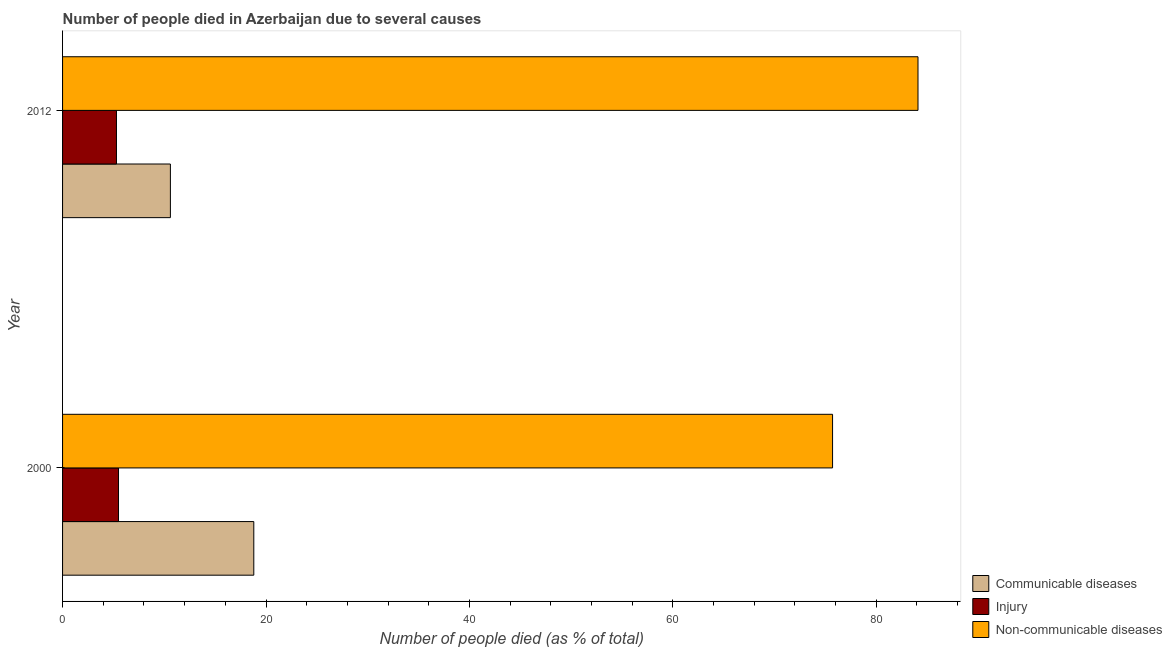Are the number of bars on each tick of the Y-axis equal?
Offer a terse response. Yes. How many bars are there on the 2nd tick from the top?
Offer a terse response. 3. What is the label of the 2nd group of bars from the top?
Your answer should be very brief. 2000. What is the number of people who dies of non-communicable diseases in 2012?
Offer a very short reply. 84.1. Across all years, what is the minimum number of people who dies of non-communicable diseases?
Keep it short and to the point. 75.7. What is the total number of people who dies of non-communicable diseases in the graph?
Ensure brevity in your answer.  159.8. What is the difference between the number of people who dies of non-communicable diseases in 2000 and the number of people who died of injury in 2012?
Your answer should be very brief. 70.4. What is the average number of people who dies of non-communicable diseases per year?
Your response must be concise. 79.9. In the year 2012, what is the difference between the number of people who died of injury and number of people who died of communicable diseases?
Make the answer very short. -5.3. In how many years, is the number of people who died of communicable diseases greater than 64 %?
Give a very brief answer. 0. What is the ratio of the number of people who died of communicable diseases in 2000 to that in 2012?
Provide a short and direct response. 1.77. Is the difference between the number of people who died of injury in 2000 and 2012 greater than the difference between the number of people who died of communicable diseases in 2000 and 2012?
Provide a succinct answer. No. In how many years, is the number of people who dies of non-communicable diseases greater than the average number of people who dies of non-communicable diseases taken over all years?
Give a very brief answer. 1. What does the 2nd bar from the top in 2000 represents?
Offer a very short reply. Injury. What does the 2nd bar from the bottom in 2012 represents?
Provide a succinct answer. Injury. How many bars are there?
Provide a succinct answer. 6. How many years are there in the graph?
Your response must be concise. 2. Are the values on the major ticks of X-axis written in scientific E-notation?
Your answer should be very brief. No. Does the graph contain any zero values?
Offer a very short reply. No. Where does the legend appear in the graph?
Provide a short and direct response. Bottom right. How are the legend labels stacked?
Make the answer very short. Vertical. What is the title of the graph?
Your response must be concise. Number of people died in Azerbaijan due to several causes. What is the label or title of the X-axis?
Offer a very short reply. Number of people died (as % of total). What is the Number of people died (as % of total) of Communicable diseases in 2000?
Provide a succinct answer. 18.8. What is the Number of people died (as % of total) in Injury in 2000?
Make the answer very short. 5.5. What is the Number of people died (as % of total) of Non-communicable diseases in 2000?
Your response must be concise. 75.7. What is the Number of people died (as % of total) of Non-communicable diseases in 2012?
Your answer should be compact. 84.1. Across all years, what is the maximum Number of people died (as % of total) in Non-communicable diseases?
Your answer should be very brief. 84.1. Across all years, what is the minimum Number of people died (as % of total) of Communicable diseases?
Your answer should be very brief. 10.6. Across all years, what is the minimum Number of people died (as % of total) in Injury?
Your response must be concise. 5.3. Across all years, what is the minimum Number of people died (as % of total) in Non-communicable diseases?
Keep it short and to the point. 75.7. What is the total Number of people died (as % of total) of Communicable diseases in the graph?
Your answer should be very brief. 29.4. What is the total Number of people died (as % of total) of Injury in the graph?
Make the answer very short. 10.8. What is the total Number of people died (as % of total) in Non-communicable diseases in the graph?
Provide a short and direct response. 159.8. What is the difference between the Number of people died (as % of total) of Communicable diseases in 2000 and that in 2012?
Make the answer very short. 8.2. What is the difference between the Number of people died (as % of total) of Communicable diseases in 2000 and the Number of people died (as % of total) of Non-communicable diseases in 2012?
Make the answer very short. -65.3. What is the difference between the Number of people died (as % of total) of Injury in 2000 and the Number of people died (as % of total) of Non-communicable diseases in 2012?
Provide a short and direct response. -78.6. What is the average Number of people died (as % of total) of Injury per year?
Make the answer very short. 5.4. What is the average Number of people died (as % of total) of Non-communicable diseases per year?
Offer a very short reply. 79.9. In the year 2000, what is the difference between the Number of people died (as % of total) of Communicable diseases and Number of people died (as % of total) of Non-communicable diseases?
Provide a succinct answer. -56.9. In the year 2000, what is the difference between the Number of people died (as % of total) in Injury and Number of people died (as % of total) in Non-communicable diseases?
Offer a very short reply. -70.2. In the year 2012, what is the difference between the Number of people died (as % of total) of Communicable diseases and Number of people died (as % of total) of Non-communicable diseases?
Provide a short and direct response. -73.5. In the year 2012, what is the difference between the Number of people died (as % of total) in Injury and Number of people died (as % of total) in Non-communicable diseases?
Your answer should be compact. -78.8. What is the ratio of the Number of people died (as % of total) in Communicable diseases in 2000 to that in 2012?
Ensure brevity in your answer.  1.77. What is the ratio of the Number of people died (as % of total) of Injury in 2000 to that in 2012?
Provide a succinct answer. 1.04. What is the ratio of the Number of people died (as % of total) of Non-communicable diseases in 2000 to that in 2012?
Provide a short and direct response. 0.9. What is the difference between the highest and the second highest Number of people died (as % of total) of Injury?
Keep it short and to the point. 0.2. What is the difference between the highest and the second highest Number of people died (as % of total) of Non-communicable diseases?
Offer a very short reply. 8.4. What is the difference between the highest and the lowest Number of people died (as % of total) of Injury?
Provide a succinct answer. 0.2. What is the difference between the highest and the lowest Number of people died (as % of total) in Non-communicable diseases?
Provide a succinct answer. 8.4. 